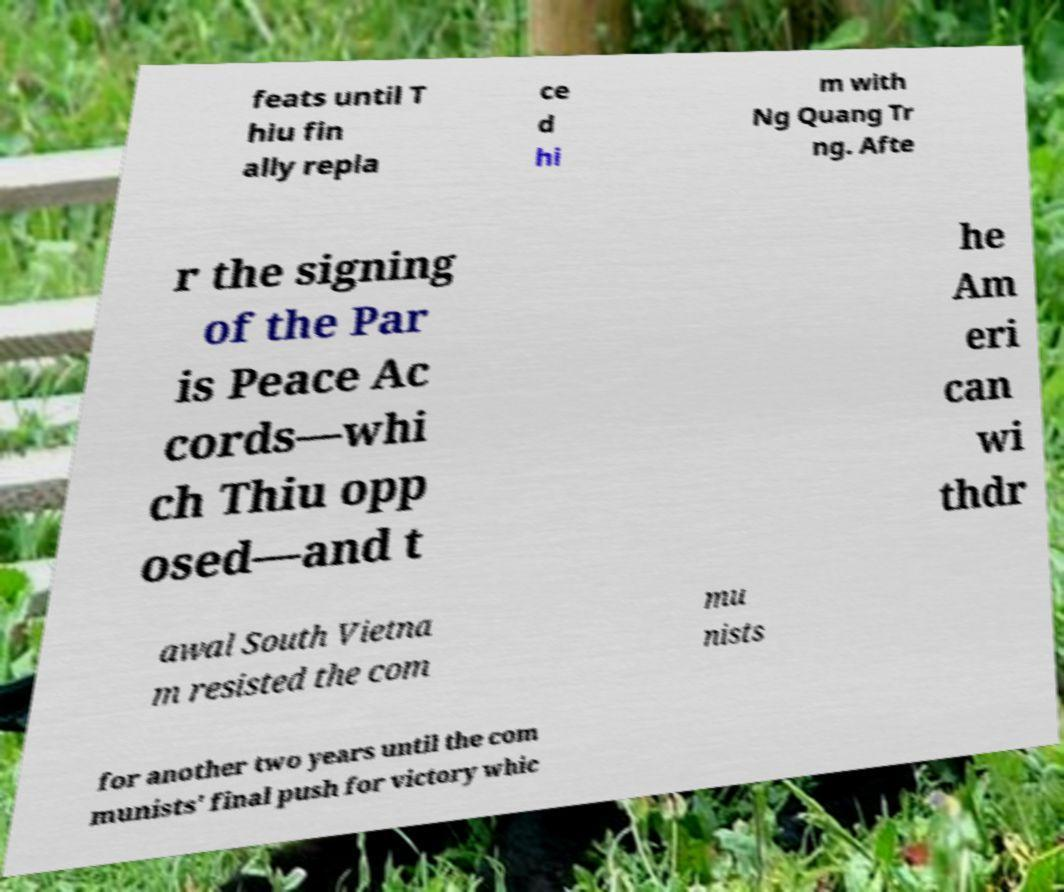Please identify and transcribe the text found in this image. feats until T hiu fin ally repla ce d hi m with Ng Quang Tr ng. Afte r the signing of the Par is Peace Ac cords—whi ch Thiu opp osed—and t he Am eri can wi thdr awal South Vietna m resisted the com mu nists for another two years until the com munists' final push for victory whic 